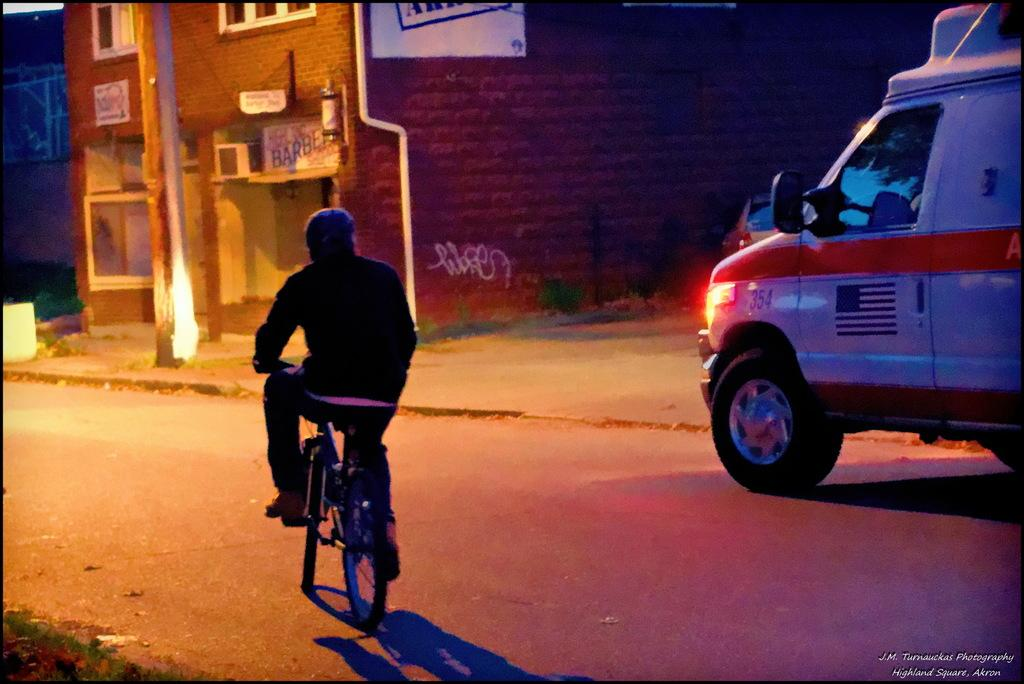Who is the person in the image? There is a man in the image. What is the man doing in the image? The man is riding a bicycle. What else can be seen on the road in the image? There is a vehicle on the road. What type of structure is visible in the image? There is a building in the image. What object is standing upright in the image? There is a pole in the image. What type of guitar is the man playing while riding the bicycle in the image? There is no guitar present in the image; the man is riding a bicycle without any musical instruments. 